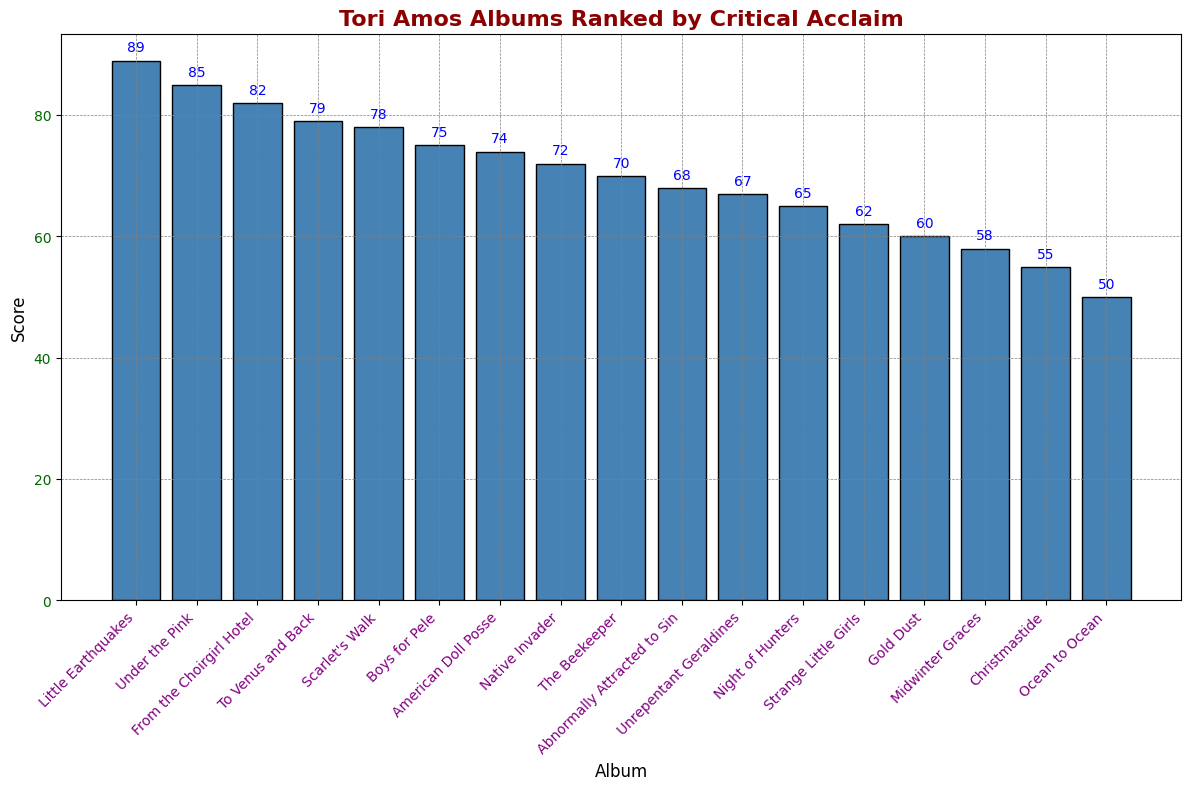Which Tori Amos album has the highest critical acclaim? By looking at the bar with the greatest height, we can determine which album ranks highest. The bar representing ‘Little Earthquakes’ is the tallest, indicating it has the highest score.
Answer: Little Earthquakes Which album has a score of 70? By examining the y-axis values and identifying the bar that aligns with the score of 70, we can find the corresponding album. The bar for ‘The Beekeeper’ aligns with a score of 70.
Answer: The Beekeeper Which album received less acclaim, 'Gold Dust' or 'Abnormally Attracted to Sin'? Comparing the heights of the bars for ‘Gold Dust’ and ‘Abnormally Attracted to Sin’, we see that ‘Gold Dust’ has a shorter bar, indicating a lower score.
Answer: Gold Dust How many albums have scores higher than 80? By counting the bars that extend above the score line of 80, we see that there are three such albums: ‘Little Earthquakes’, ‘Under the Pink’, and ‘From the Choirgirl Hotel’.
Answer: 3 What's the difference in score between 'Under the Pink' and 'To Venus and Back'? To find the difference, we need the scores of 'Under the Pink' and 'To Venus and Back'. 'Under the Pink' has a score of 85, and 'To Venus and Back' has a score of 79. The difference is 85 - 79.
Answer: 6 Which album has the lowest critical acclaim? By identifying the shortest bar in the figure, we can determine which album has the lowest score. The shortest bar represents ‘Ocean to Ocean’.
Answer: Ocean to Ocean What score does 'Scarlet's Walk' have? By locating the bar labeled ‘Scarlet's Walk’ and checking its height against the y-axis, we see that it aligns with the score of 78.
Answer: 78 Which albums have scores between 60 and 70? By identifying the bars whose heights fall within the 60 to 70 range on the y-axis, we find ‘Abnormally Attracted to Sin’, ‘Unrepentant Geraldines’, and ‘Night of Hunters’.
Answer: Abnormally Attracted to Sin, Unrepentant Geraldines, Night of Hunters What's the average score of 'Native Invader', 'The Beekeeper', and 'Abnormally Attracted to Sin'? To find this average, first add their scores: 72 (Native Invader) + 70 (The Beekeeper) + 68 (Abnormally Attracted to Sin) = 210. Then divide by 3, which gives 210/3.
Answer: 70 What's the combined score of the top three albums? The top three albums are ‘Little Earthquakes’ (89), ‘Under the Pink’ (85), and ‘From the Choirgirl Hotel’ (82). Adding these scores together: 89 + 85 + 82.
Answer: 256 